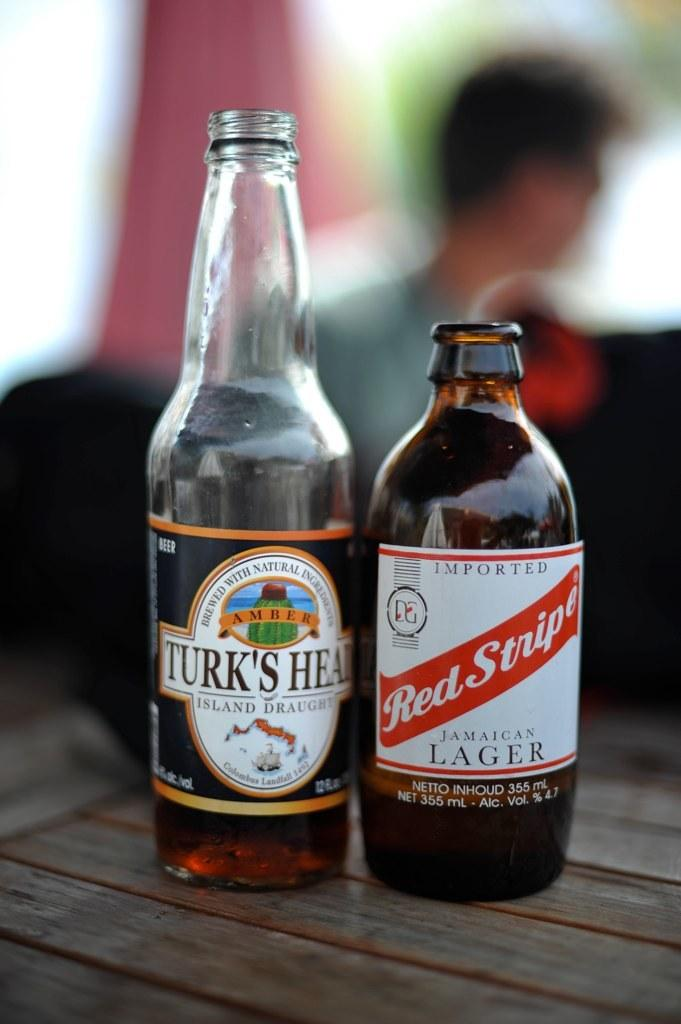<image>
Provide a brief description of the given image. A white bottle of Turk's Head Amber color beer brewed with natural ingredients and a dark color bottle of Red Stripe Jamaican Lager by DG 